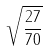<formula> <loc_0><loc_0><loc_500><loc_500>\sqrt { \frac { 2 7 } { 7 0 } }</formula> 